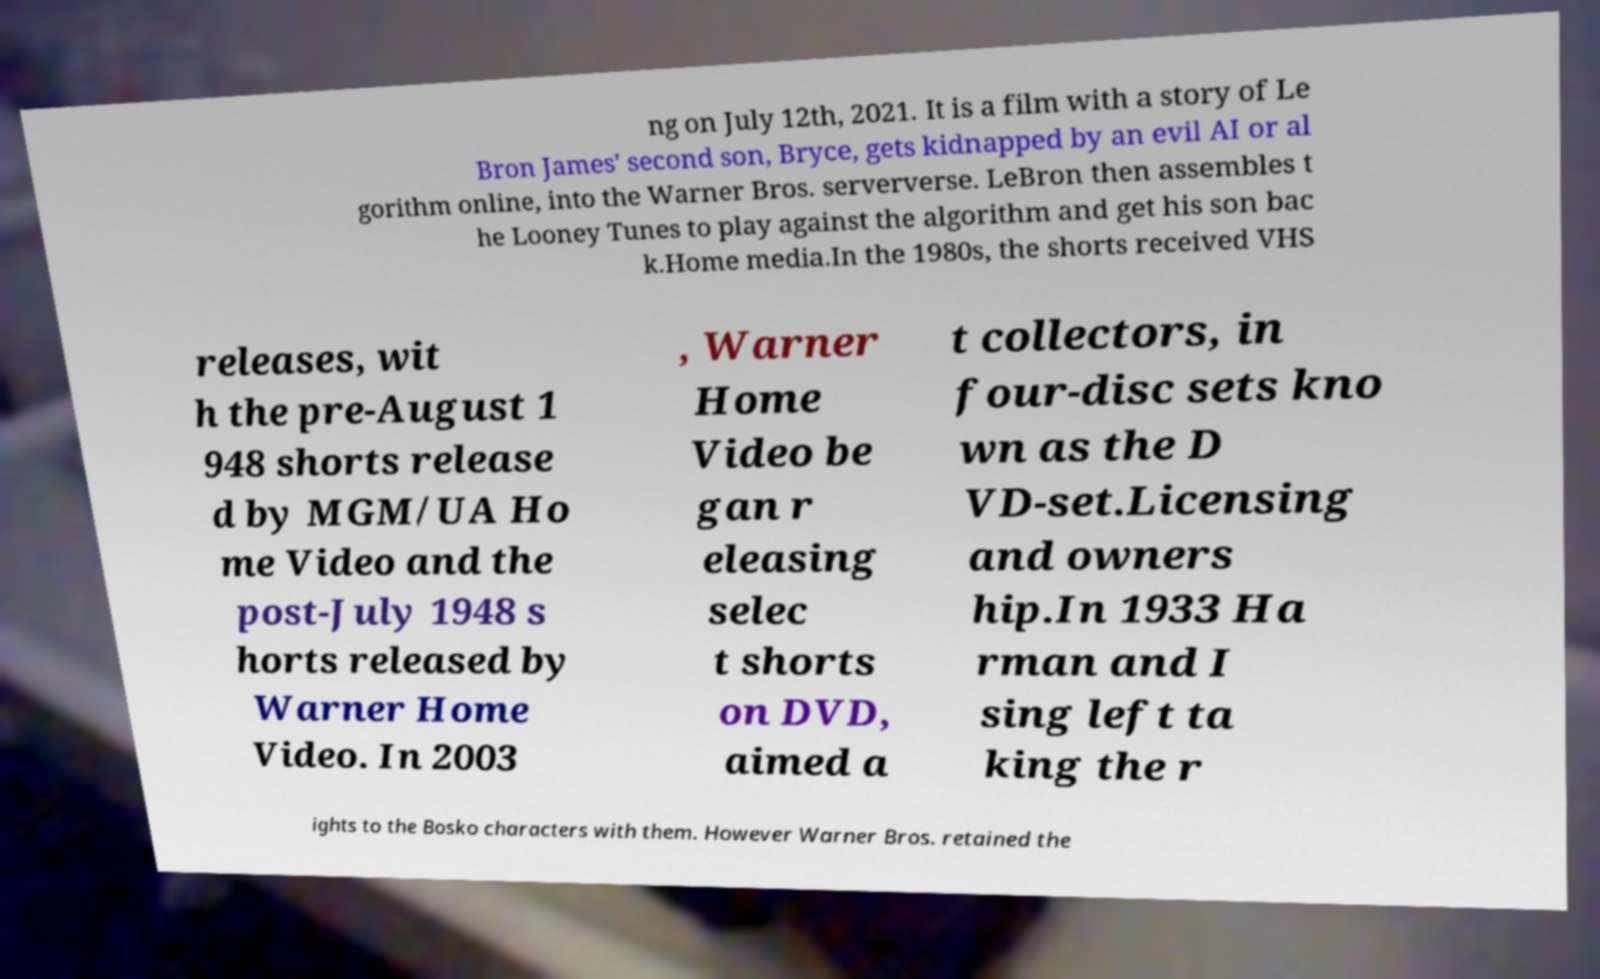Could you extract and type out the text from this image? ng on July 12th, 2021. It is a film with a story of Le Bron James' second son, Bryce, gets kidnapped by an evil AI or al gorithm online, into the Warner Bros. serververse. LeBron then assembles t he Looney Tunes to play against the algorithm and get his son bac k.Home media.In the 1980s, the shorts received VHS releases, wit h the pre-August 1 948 shorts release d by MGM/UA Ho me Video and the post-July 1948 s horts released by Warner Home Video. In 2003 , Warner Home Video be gan r eleasing selec t shorts on DVD, aimed a t collectors, in four-disc sets kno wn as the D VD-set.Licensing and owners hip.In 1933 Ha rman and I sing left ta king the r ights to the Bosko characters with them. However Warner Bros. retained the 